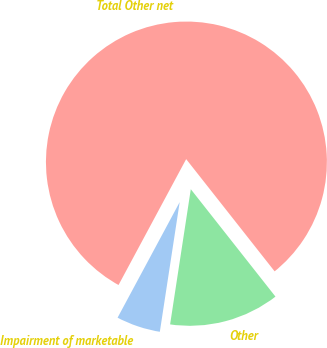<chart> <loc_0><loc_0><loc_500><loc_500><pie_chart><fcel>Impairment of marketable<fcel>Other<fcel>Total Other net<nl><fcel>5.43%<fcel>13.04%<fcel>81.52%<nl></chart> 